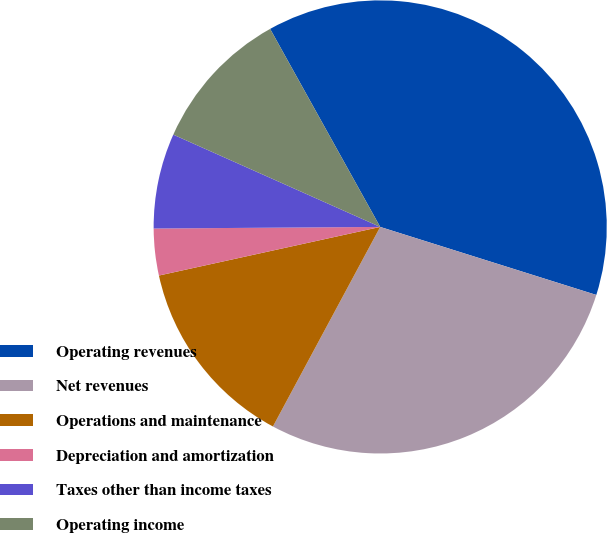Convert chart. <chart><loc_0><loc_0><loc_500><loc_500><pie_chart><fcel>Operating revenues<fcel>Net revenues<fcel>Operations and maintenance<fcel>Depreciation and amortization<fcel>Taxes other than income taxes<fcel>Operating income<nl><fcel>37.93%<fcel>28.0%<fcel>13.71%<fcel>3.33%<fcel>6.79%<fcel>10.25%<nl></chart> 